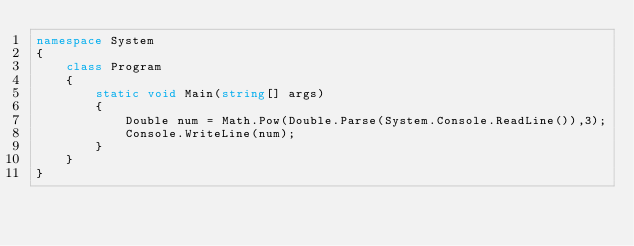<code> <loc_0><loc_0><loc_500><loc_500><_C#_>namespace System
{
    class Program
    {
        static void Main(string[] args)
        {
            Double num = Math.Pow(Double.Parse(System.Console.ReadLine()),3);
            Console.WriteLine(num);
        }
    }
}</code> 